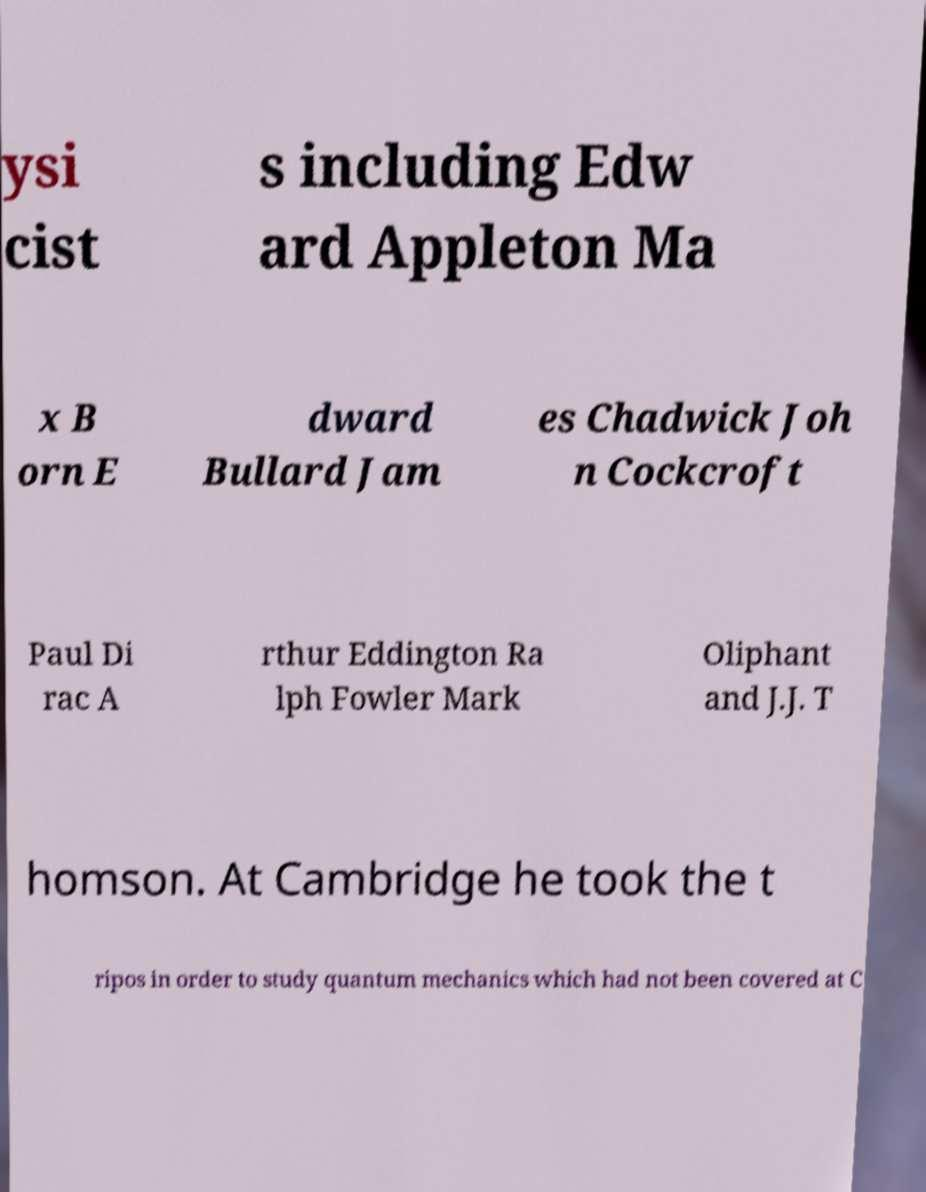Please identify and transcribe the text found in this image. ysi cist s including Edw ard Appleton Ma x B orn E dward Bullard Jam es Chadwick Joh n Cockcroft Paul Di rac A rthur Eddington Ra lph Fowler Mark Oliphant and J.J. T homson. At Cambridge he took the t ripos in order to study quantum mechanics which had not been covered at C 